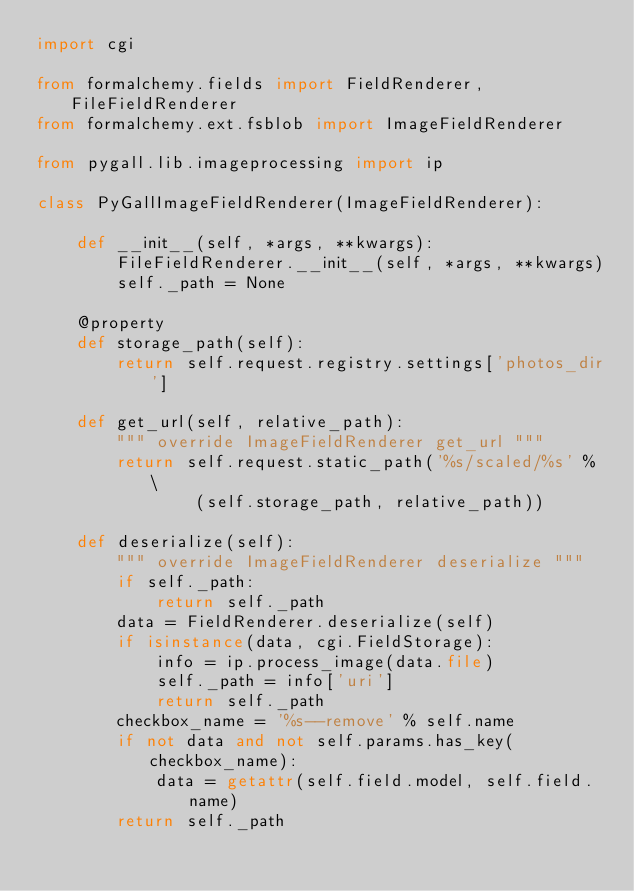<code> <loc_0><loc_0><loc_500><loc_500><_Python_>import cgi

from formalchemy.fields import FieldRenderer, FileFieldRenderer
from formalchemy.ext.fsblob import ImageFieldRenderer

from pygall.lib.imageprocessing import ip

class PyGallImageFieldRenderer(ImageFieldRenderer):

    def __init__(self, *args, **kwargs):
        FileFieldRenderer.__init__(self, *args, **kwargs)
        self._path = None

    @property
    def storage_path(self):
        return self.request.registry.settings['photos_dir']

    def get_url(self, relative_path):
        """ override ImageFieldRenderer get_url """
        return self.request.static_path('%s/scaled/%s' % \
                (self.storage_path, relative_path))

    def deserialize(self):
        """ override ImageFieldRenderer deserialize """
        if self._path:
            return self._path
        data = FieldRenderer.deserialize(self)
        if isinstance(data, cgi.FieldStorage):
            info = ip.process_image(data.file)
            self._path = info['uri']
            return self._path
        checkbox_name = '%s--remove' % self.name
        if not data and not self.params.has_key(checkbox_name):
            data = getattr(self.field.model, self.field.name)
        return self._path

</code> 